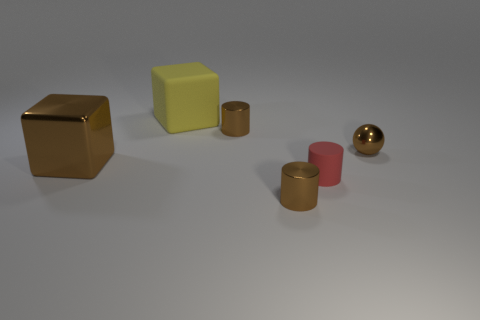Add 1 metallic spheres. How many objects exist? 7 Subtract all spheres. How many objects are left? 5 Add 5 yellow cubes. How many yellow cubes exist? 6 Subtract 0 green cylinders. How many objects are left? 6 Subtract all yellow matte blocks. Subtract all big brown cubes. How many objects are left? 4 Add 1 small brown metallic spheres. How many small brown metallic spheres are left? 2 